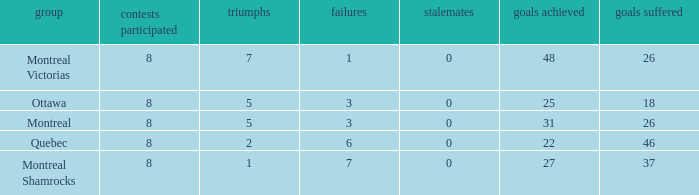For teams with fewer than 5 wins, goals against over 37, and fewer than 8 games played, what is the average number of ties? None. 